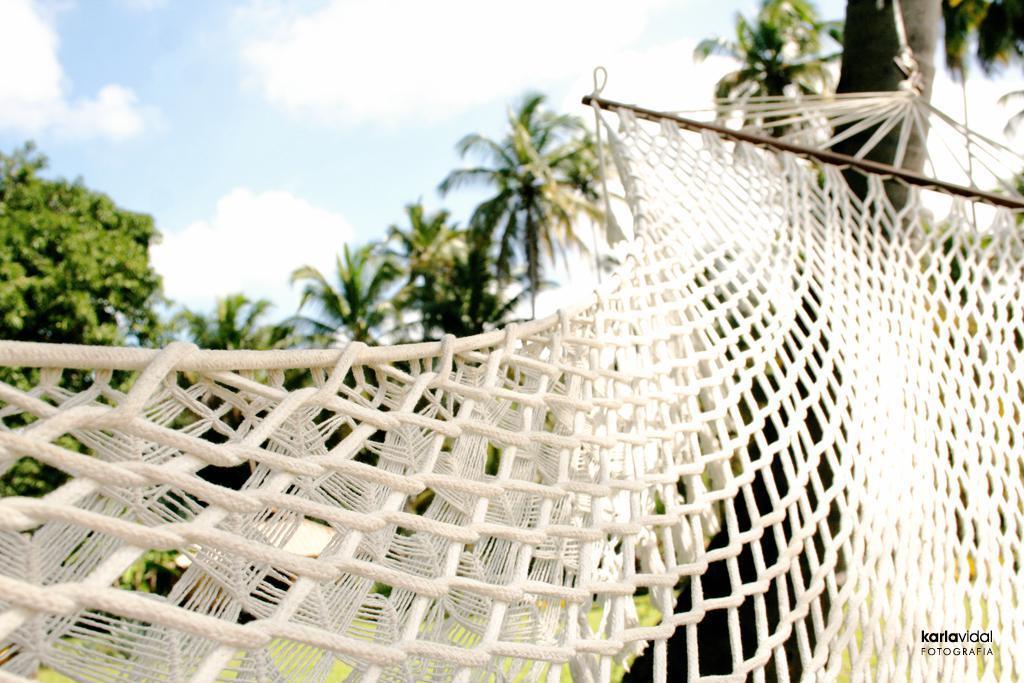In one or two sentences, can you explain what this image depicts? In this picture I can see a thing in front, which looks like a swing and I see the watermark on the bottom right corner of this image. In the background I see number of trees and I see the sky. 